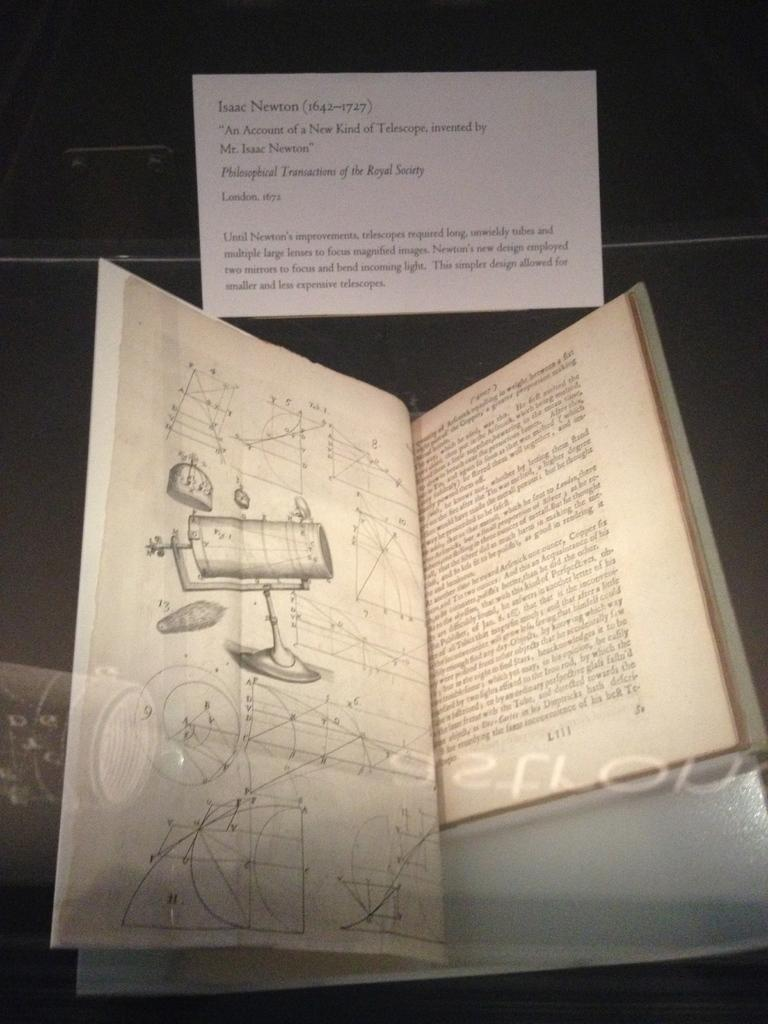What is the main object in the image? There is a book in the image. What can be found inside the book? The book has pictures and text. Is there anything else written in the image? Yes, there is a note in the image. What is on the note? The note has text. Where is the mint plant located in the image? There is no mint plant present in the image. How does the mailbox open in the image? There is no mailbox present in the image. 